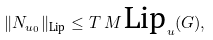<formula> <loc_0><loc_0><loc_500><loc_500>\| N _ { u _ { 0 } } \| _ { \text {Lip} } \leq T \, M \, \text {Lip} _ { u } ( G ) ,</formula> 